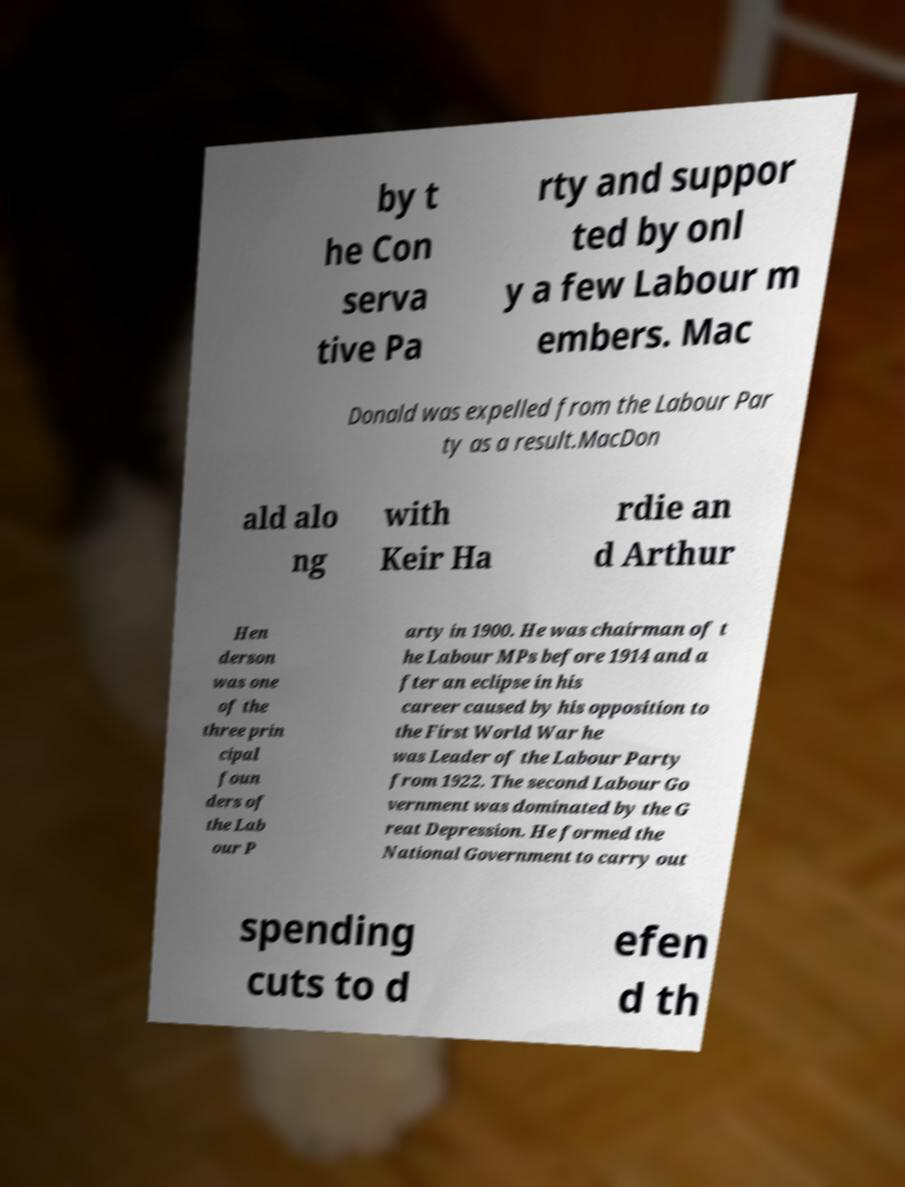Please read and relay the text visible in this image. What does it say? by t he Con serva tive Pa rty and suppor ted by onl y a few Labour m embers. Mac Donald was expelled from the Labour Par ty as a result.MacDon ald alo ng with Keir Ha rdie an d Arthur Hen derson was one of the three prin cipal foun ders of the Lab our P arty in 1900. He was chairman of t he Labour MPs before 1914 and a fter an eclipse in his career caused by his opposition to the First World War he was Leader of the Labour Party from 1922. The second Labour Go vernment was dominated by the G reat Depression. He formed the National Government to carry out spending cuts to d efen d th 